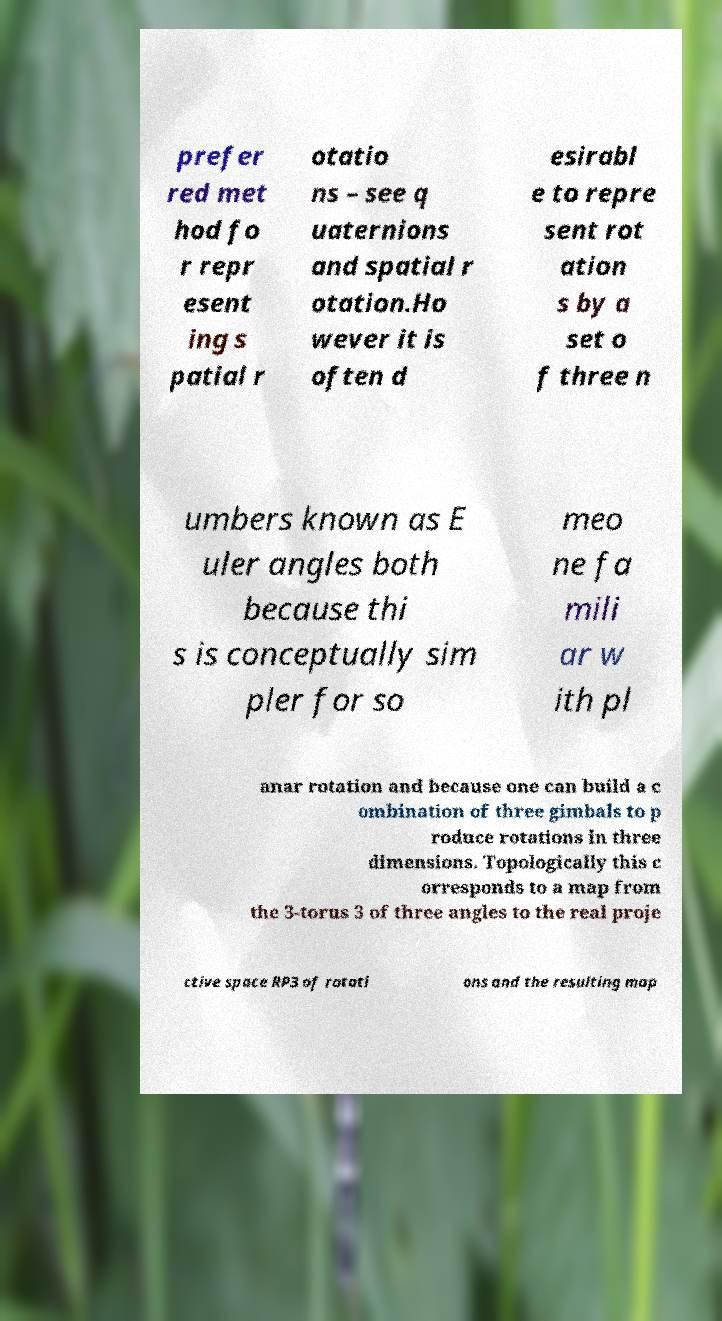Please read and relay the text visible in this image. What does it say? prefer red met hod fo r repr esent ing s patial r otatio ns – see q uaternions and spatial r otation.Ho wever it is often d esirabl e to repre sent rot ation s by a set o f three n umbers known as E uler angles both because thi s is conceptually sim pler for so meo ne fa mili ar w ith pl anar rotation and because one can build a c ombination of three gimbals to p roduce rotations in three dimensions. Topologically this c orresponds to a map from the 3-torus 3 of three angles to the real proje ctive space RP3 of rotati ons and the resulting map 